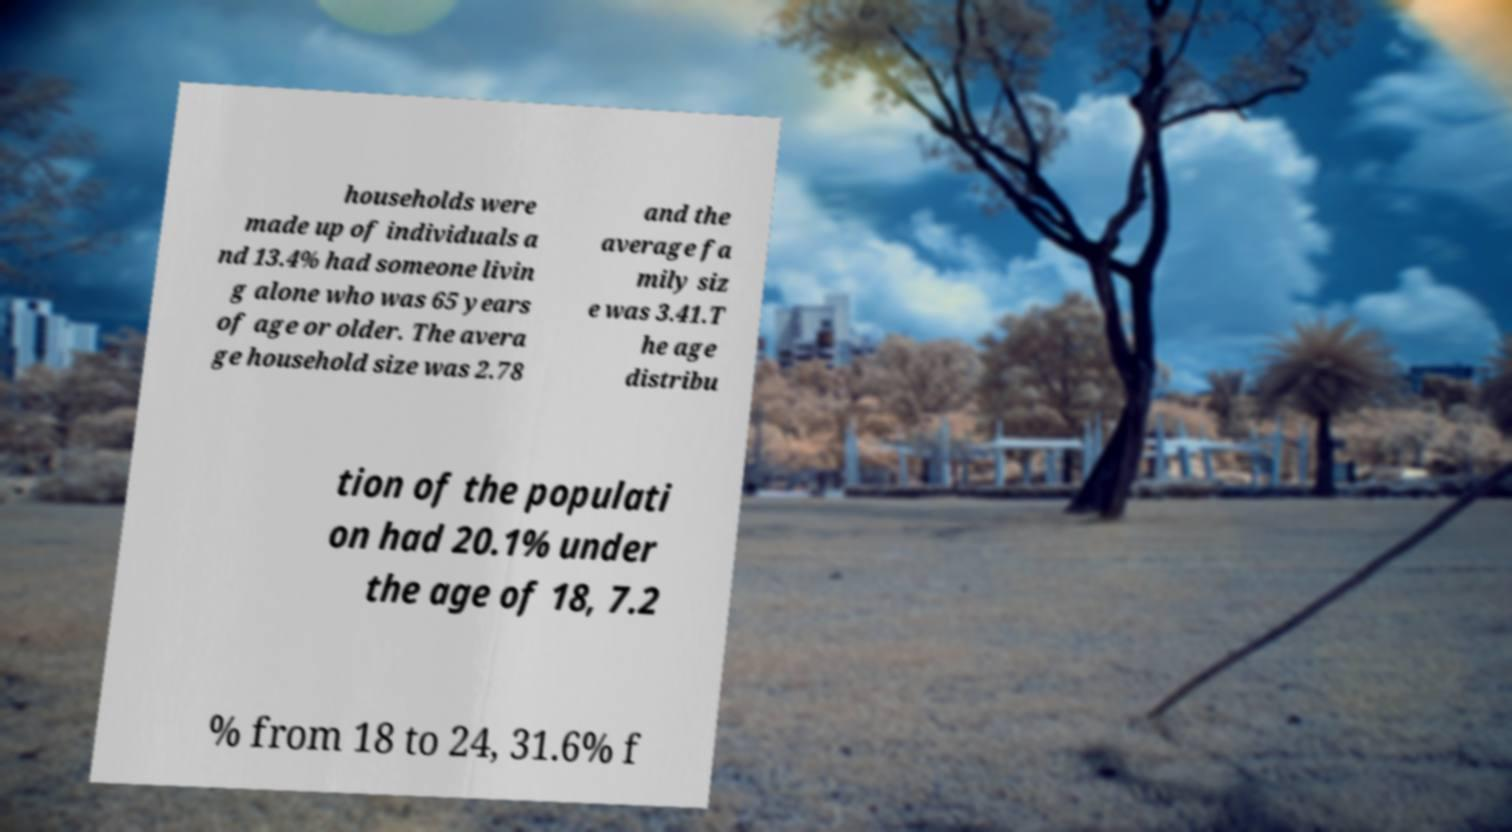Can you read and provide the text displayed in the image?This photo seems to have some interesting text. Can you extract and type it out for me? households were made up of individuals a nd 13.4% had someone livin g alone who was 65 years of age or older. The avera ge household size was 2.78 and the average fa mily siz e was 3.41.T he age distribu tion of the populati on had 20.1% under the age of 18, 7.2 % from 18 to 24, 31.6% f 